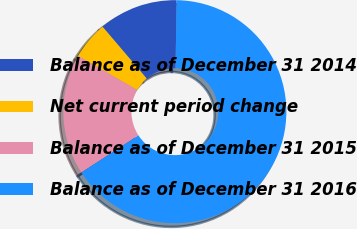<chart> <loc_0><loc_0><loc_500><loc_500><pie_chart><fcel>Balance as of December 31 2014<fcel>Net current period change<fcel>Balance as of December 31 2015<fcel>Balance as of December 31 2016<nl><fcel>11.48%<fcel>5.47%<fcel>17.49%<fcel>65.57%<nl></chart> 